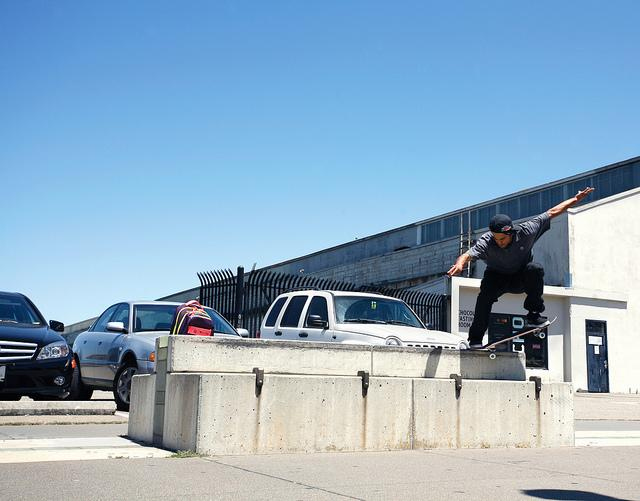What is the man on the board doing on the ledge? skateboarding 